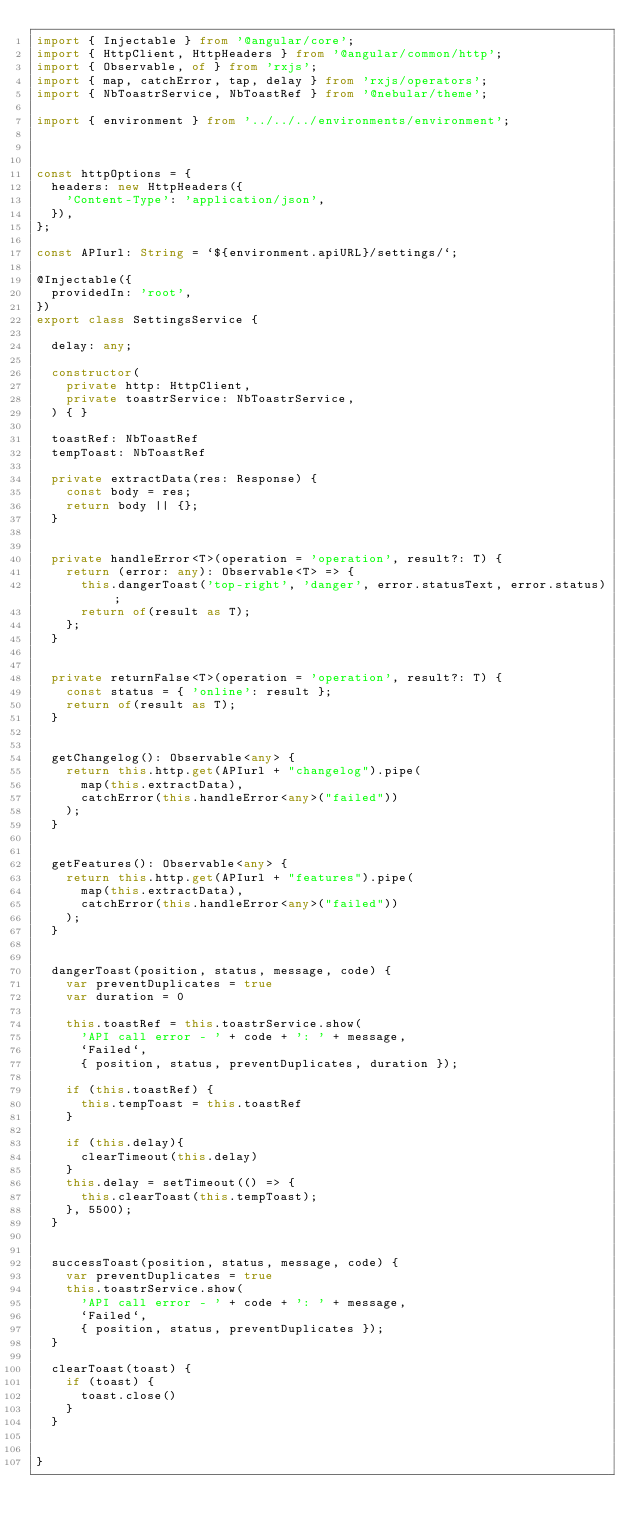Convert code to text. <code><loc_0><loc_0><loc_500><loc_500><_TypeScript_>import { Injectable } from '@angular/core';
import { HttpClient, HttpHeaders } from '@angular/common/http';
import { Observable, of } from 'rxjs';
import { map, catchError, tap, delay } from 'rxjs/operators';
import { NbToastrService, NbToastRef } from '@nebular/theme';

import { environment } from '../../../environments/environment';



const httpOptions = {
  headers: new HttpHeaders({
    'Content-Type': 'application/json',
  }),
};

const APIurl: String = `${environment.apiURL}/settings/`;

@Injectable({
  providedIn: 'root',
})
export class SettingsService {

  delay: any;

  constructor(
    private http: HttpClient,
    private toastrService: NbToastrService,
  ) { }

  toastRef: NbToastRef
  tempToast: NbToastRef

  private extractData(res: Response) {
    const body = res;
    return body || {};
  }


  private handleError<T>(operation = 'operation', result?: T) {
    return (error: any): Observable<T> => {
      this.dangerToast('top-right', 'danger', error.statusText, error.status);
      return of(result as T);
    };
  }


  private returnFalse<T>(operation = 'operation', result?: T) {
    const status = { 'online': result };
    return of(result as T);
  }


  getChangelog(): Observable<any> {
    return this.http.get(APIurl + "changelog").pipe(
      map(this.extractData),
      catchError(this.handleError<any>("failed"))
    );
  }


  getFeatures(): Observable<any> {
    return this.http.get(APIurl + "features").pipe(
      map(this.extractData),
      catchError(this.handleError<any>("failed"))
    );
  }


  dangerToast(position, status, message, code) {
    var preventDuplicates = true
    var duration = 0

    this.toastRef = this.toastrService.show(
      'API call error - ' + code + ': ' + message,
      `Failed`,
      { position, status, preventDuplicates, duration });

    if (this.toastRef) {
      this.tempToast = this.toastRef
    }

    if (this.delay){
      clearTimeout(this.delay)
    }
    this.delay = setTimeout(() => {
      this.clearToast(this.tempToast);
    }, 5500);
  }

  
  successToast(position, status, message, code) {
    var preventDuplicates = true
    this.toastrService.show(
      'API call error - ' + code + ': ' + message,
      `Failed`,
      { position, status, preventDuplicates });
  }

  clearToast(toast) {
    if (toast) {
      toast.close()
    }
  }


}
</code> 